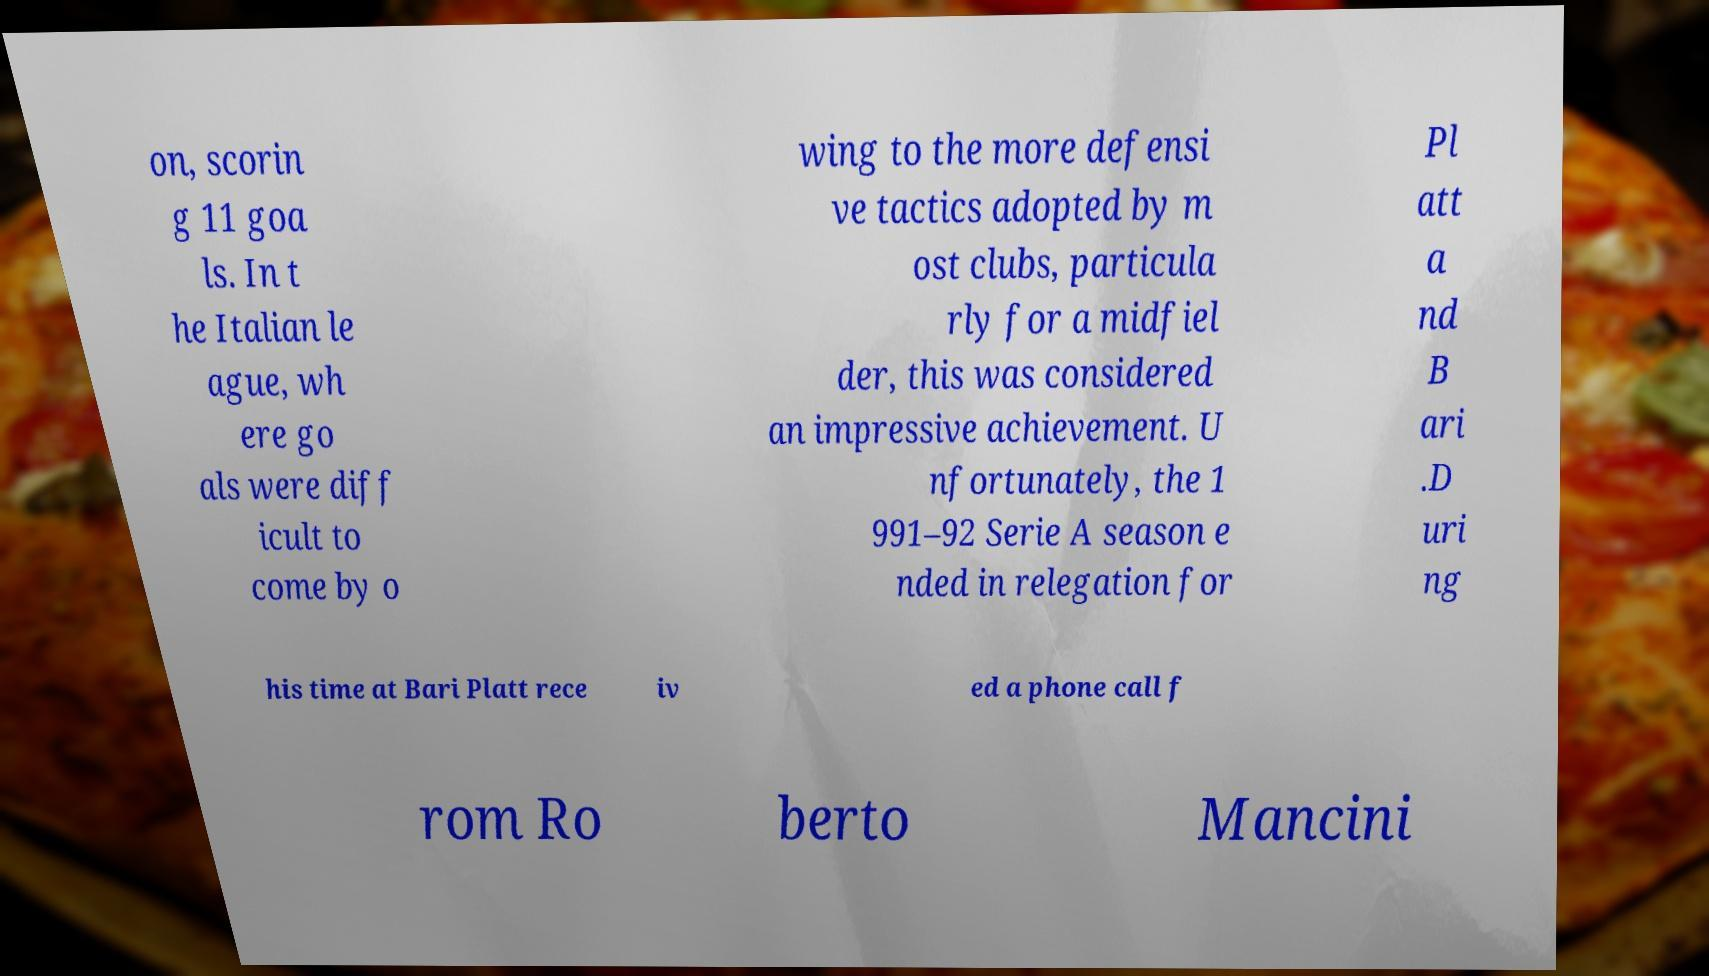Can you accurately transcribe the text from the provided image for me? on, scorin g 11 goa ls. In t he Italian le ague, wh ere go als were diff icult to come by o wing to the more defensi ve tactics adopted by m ost clubs, particula rly for a midfiel der, this was considered an impressive achievement. U nfortunately, the 1 991–92 Serie A season e nded in relegation for Pl att a nd B ari .D uri ng his time at Bari Platt rece iv ed a phone call f rom Ro berto Mancini 